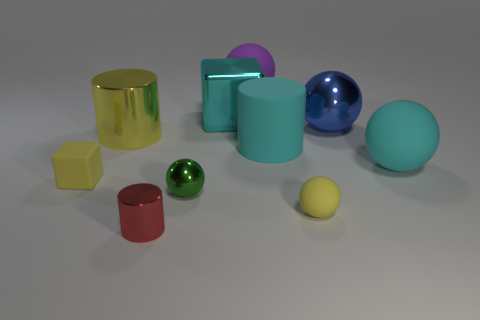There is a big sphere that is the same color as the metal cube; what material is it?
Keep it short and to the point. Rubber. Is there anything else that has the same shape as the green thing?
Your answer should be compact. Yes. There is a matte thing left of the yellow object that is behind the cylinder on the right side of the cyan cube; what is its color?
Provide a short and direct response. Yellow. How many big objects are either cyan cubes or green things?
Make the answer very short. 1. Are there an equal number of large yellow things that are right of the red metallic object and big green things?
Offer a very short reply. Yes. Are there any big cyan rubber objects on the left side of the small red metallic cylinder?
Your response must be concise. No. What number of shiny things are either blue balls or tiny yellow things?
Your answer should be very brief. 1. How many large yellow cylinders are right of the cyan rubber sphere?
Ensure brevity in your answer.  0. Are there any purple balls that have the same size as the cyan metallic object?
Your answer should be very brief. Yes. Is there a tiny object that has the same color as the matte cube?
Provide a succinct answer. Yes. 